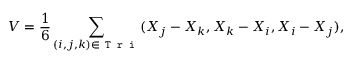Convert formula to latex. <formula><loc_0><loc_0><loc_500><loc_500>V = \frac { 1 } { 6 } \sum _ { ( i , j , k ) \in T r i } ( \boldsymbol X _ { j } - \boldsymbol X _ { k } , \boldsymbol X _ { k } - \boldsymbol X _ { i } , \boldsymbol X _ { i } - \boldsymbol X _ { j } ) ,</formula> 